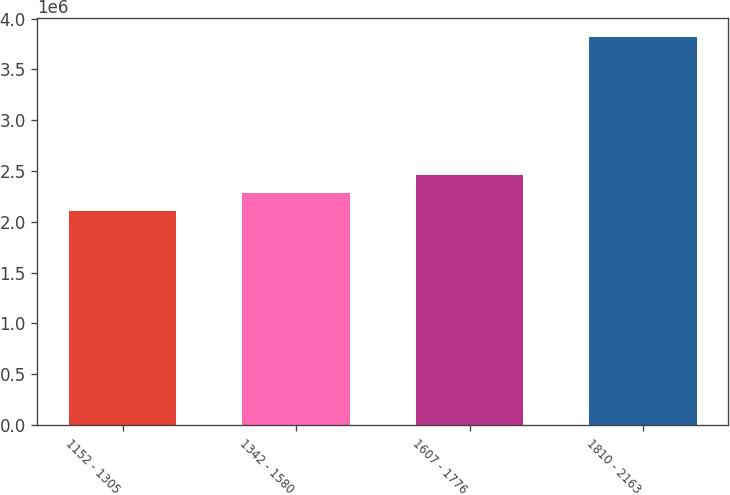Convert chart. <chart><loc_0><loc_0><loc_500><loc_500><bar_chart><fcel>1152 - 1305<fcel>1342 - 1580<fcel>1607 - 1776<fcel>1810 - 2163<nl><fcel>2.10732e+06<fcel>2.28867e+06<fcel>2.45976e+06<fcel>3.81828e+06<nl></chart> 